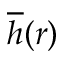Convert formula to latex. <formula><loc_0><loc_0><loc_500><loc_500>\overline { h } ( r )</formula> 